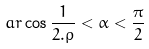Convert formula to latex. <formula><loc_0><loc_0><loc_500><loc_500>a r \cos \frac { 1 } { 2 . \rho } < \alpha < \frac { \pi } { 2 }</formula> 